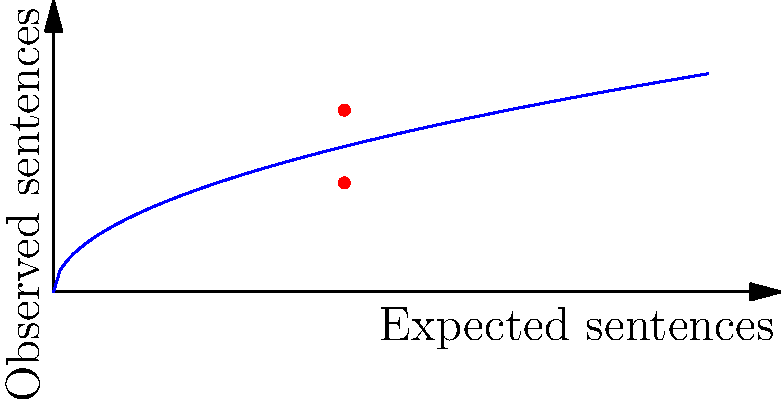In a funnel plot showing sentencing outcomes, two data points at the expected sentence of 4 years have observed sentences of 2.5 and 1.5 years. If the control limits follow a square root function, what is the angle of divergence (in degrees) between these two points and the expected outcome line? To calculate the angle of divergence:

1) The control limit function is given by $y = \sqrt{x}$

2) At $x = 4$, the expected outcome is $y = \sqrt{4} = 2$

3) The two observed points are (4, 2.5) and (4, 1.5)

4) Calculate the angles for each point:
   For (4, 2.5): $\theta_1 = \arctan(\frac{2.5 - 2}{4 - 4}) = 90°$
   For (4, 1.5): $\theta_2 = \arctan(\frac{1.5 - 2}{4 - 4}) = -90°$

5) The angle of divergence is the difference:
   $\text{Angle of divergence} = |\theta_1 - \theta_2| = |90° - (-90°)| = 180°$

Therefore, the angle of divergence between these two points and the expected outcome line is 180°.
Answer: 180° 